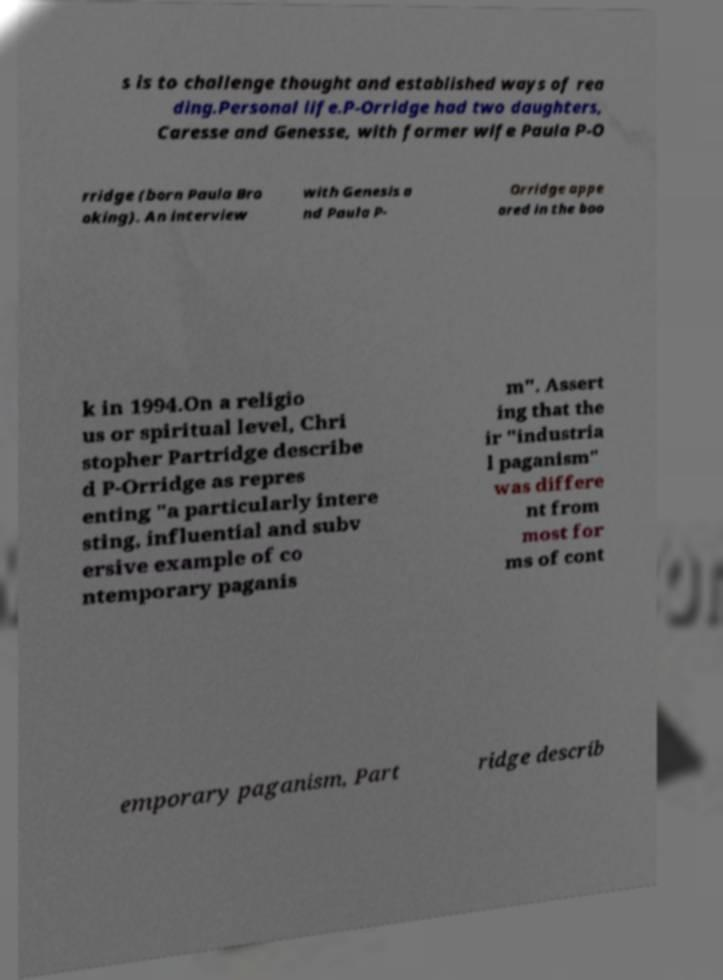Could you assist in decoding the text presented in this image and type it out clearly? s is to challenge thought and established ways of rea ding.Personal life.P-Orridge had two daughters, Caresse and Genesse, with former wife Paula P-O rridge (born Paula Bro oking). An interview with Genesis a nd Paula P- Orridge appe ared in the boo k in 1994.On a religio us or spiritual level, Chri stopher Partridge describe d P-Orridge as repres enting "a particularly intere sting, influential and subv ersive example of co ntemporary paganis m". Assert ing that the ir "industria l paganism" was differe nt from most for ms of cont emporary paganism, Part ridge describ 